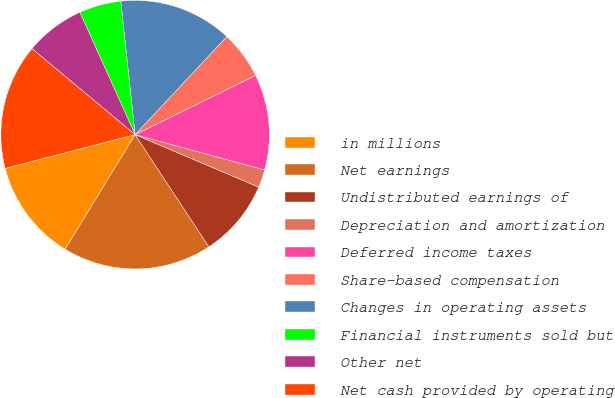Convert chart to OTSL. <chart><loc_0><loc_0><loc_500><loc_500><pie_chart><fcel>in millions<fcel>Net earnings<fcel>Undistributed earnings of<fcel>Depreciation and amortization<fcel>Deferred income taxes<fcel>Share-based compensation<fcel>Changes in operating assets<fcel>Financial instruments sold but<fcel>Other net<fcel>Net cash provided by operating<nl><fcel>12.23%<fcel>17.99%<fcel>9.35%<fcel>2.16%<fcel>11.51%<fcel>5.76%<fcel>13.67%<fcel>5.04%<fcel>7.19%<fcel>15.11%<nl></chart> 